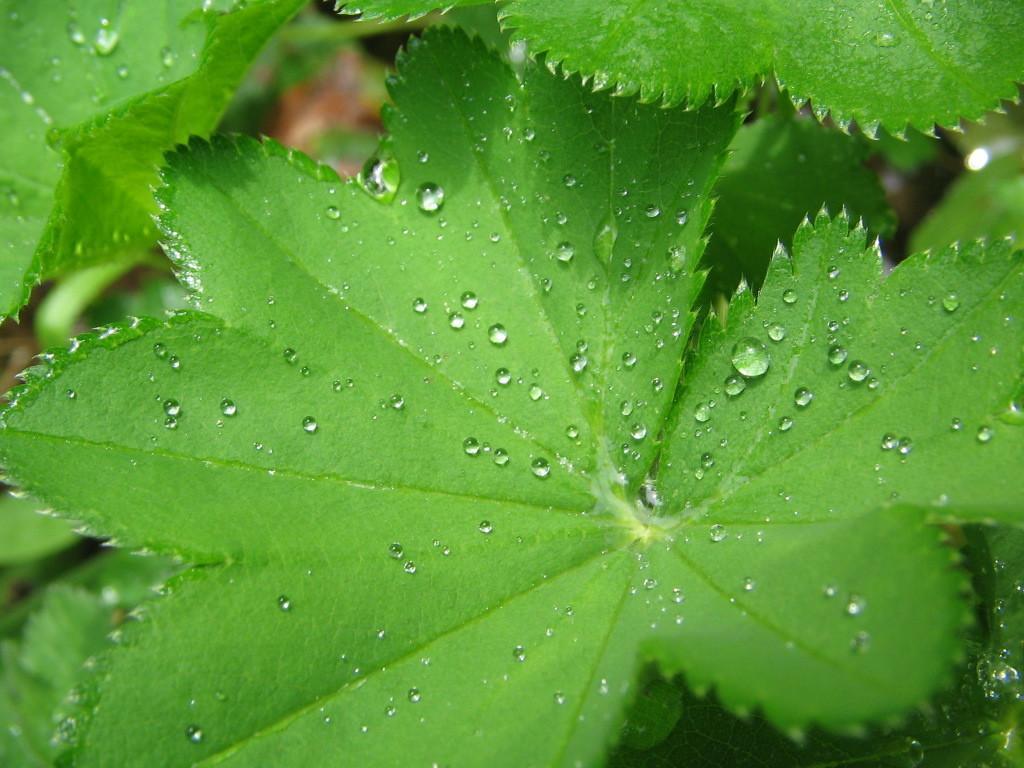Can you describe this image briefly? In this image we can see there are leaves. On the leaves there are some water drops. 